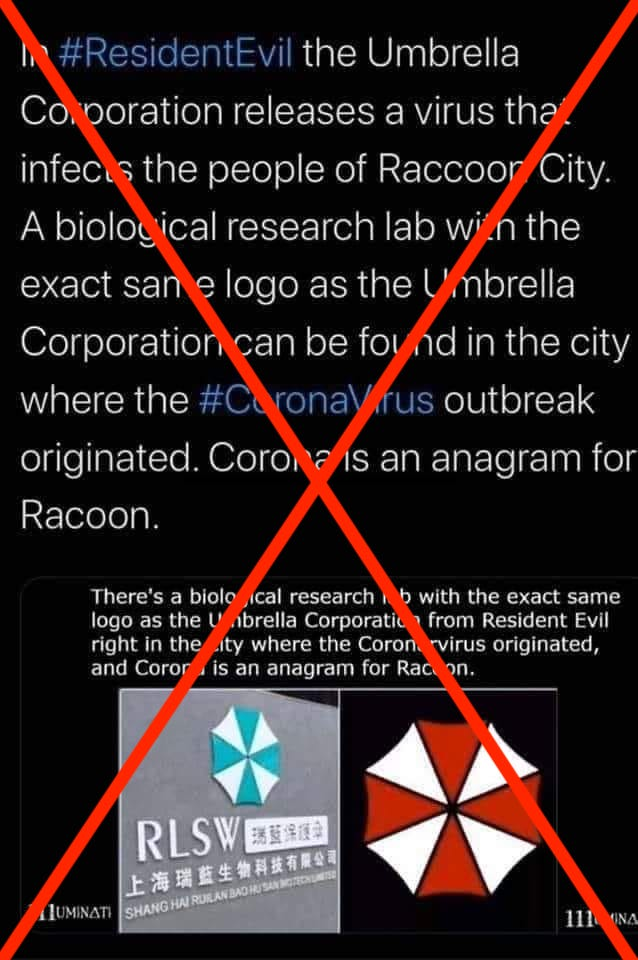'In 'Resident Evil' the Umbrella Corporation releases a virus that infects the people of Raccoon City. A biological research lab with the exact same logo as the Umbrella Corporation can be found in the city where the coronavirus outbreak originated.' Is this factually correct? This statement is not factually correct. It draws on fictional elements from the 'Resident Evil' video game series and attempts to connect them to real-life events without any basis. The logo of the actual biotech company, Shang Hai Ruilan Bao Hu San Biotech Limited, bears superficial similarity to that of the Umbrella Corporation's emblem, but the colors and design details are distinct. Additionally, the narrative of the video game is purely fictional and has no connection to the actual outbreak of the coronavirus, which scientific consensus concludes likely has zoonotic origins. Assertions like these are often associated with misinformation, which can cause unnecessary fear and confusion. It's essential to rely on verified information from reputable sources such as health departments and major health organizations when dealing with issues related to public health. 